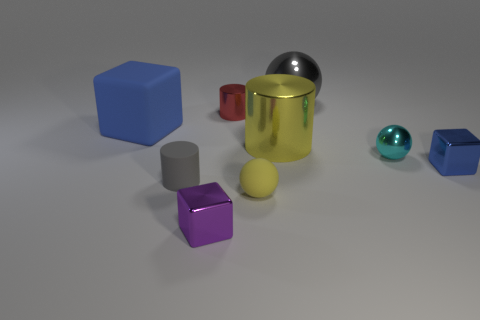What material is the other block that is the same color as the rubber block?
Offer a terse response. Metal. There is a thing that is the same color as the large ball; what shape is it?
Offer a terse response. Cylinder. Is the size of the purple shiny block the same as the blue cube that is left of the cyan shiny sphere?
Offer a terse response. No. Are there fewer cylinders that are behind the large yellow cylinder than red shiny objects?
Provide a short and direct response. No. How many other metallic cylinders are the same color as the tiny metallic cylinder?
Give a very brief answer. 0. Is the number of metallic blocks less than the number of large gray things?
Provide a short and direct response. No. Is the red thing made of the same material as the purple object?
Your response must be concise. Yes. What number of other objects are there of the same size as the gray matte thing?
Keep it short and to the point. 5. There is a small cylinder that is left of the block that is in front of the tiny gray rubber thing; what is its color?
Ensure brevity in your answer.  Gray. What number of other things are there of the same shape as the tiny cyan metal thing?
Give a very brief answer. 2. 